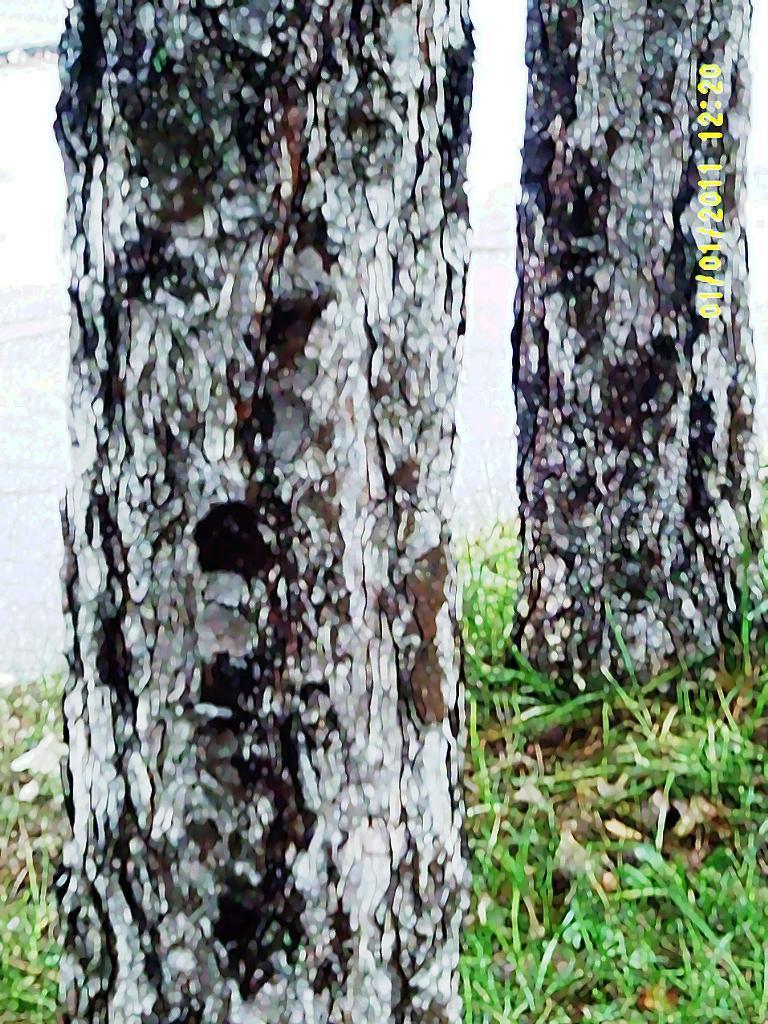How would you summarize this image in a sentence or two? There are two trees and grass on the ground, near the water. In the right top corner, there is a watermark. 